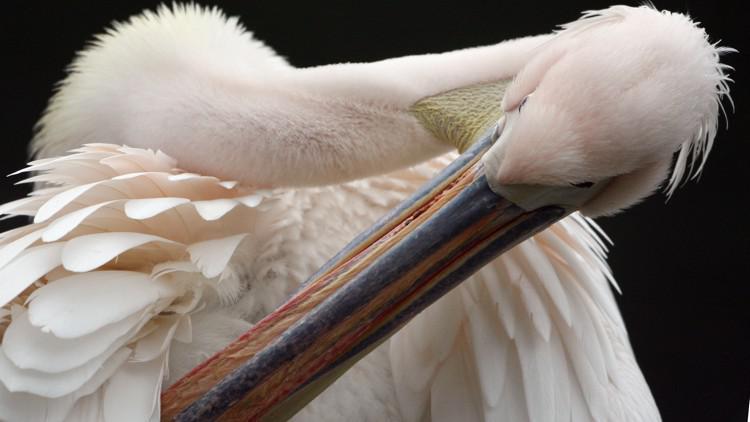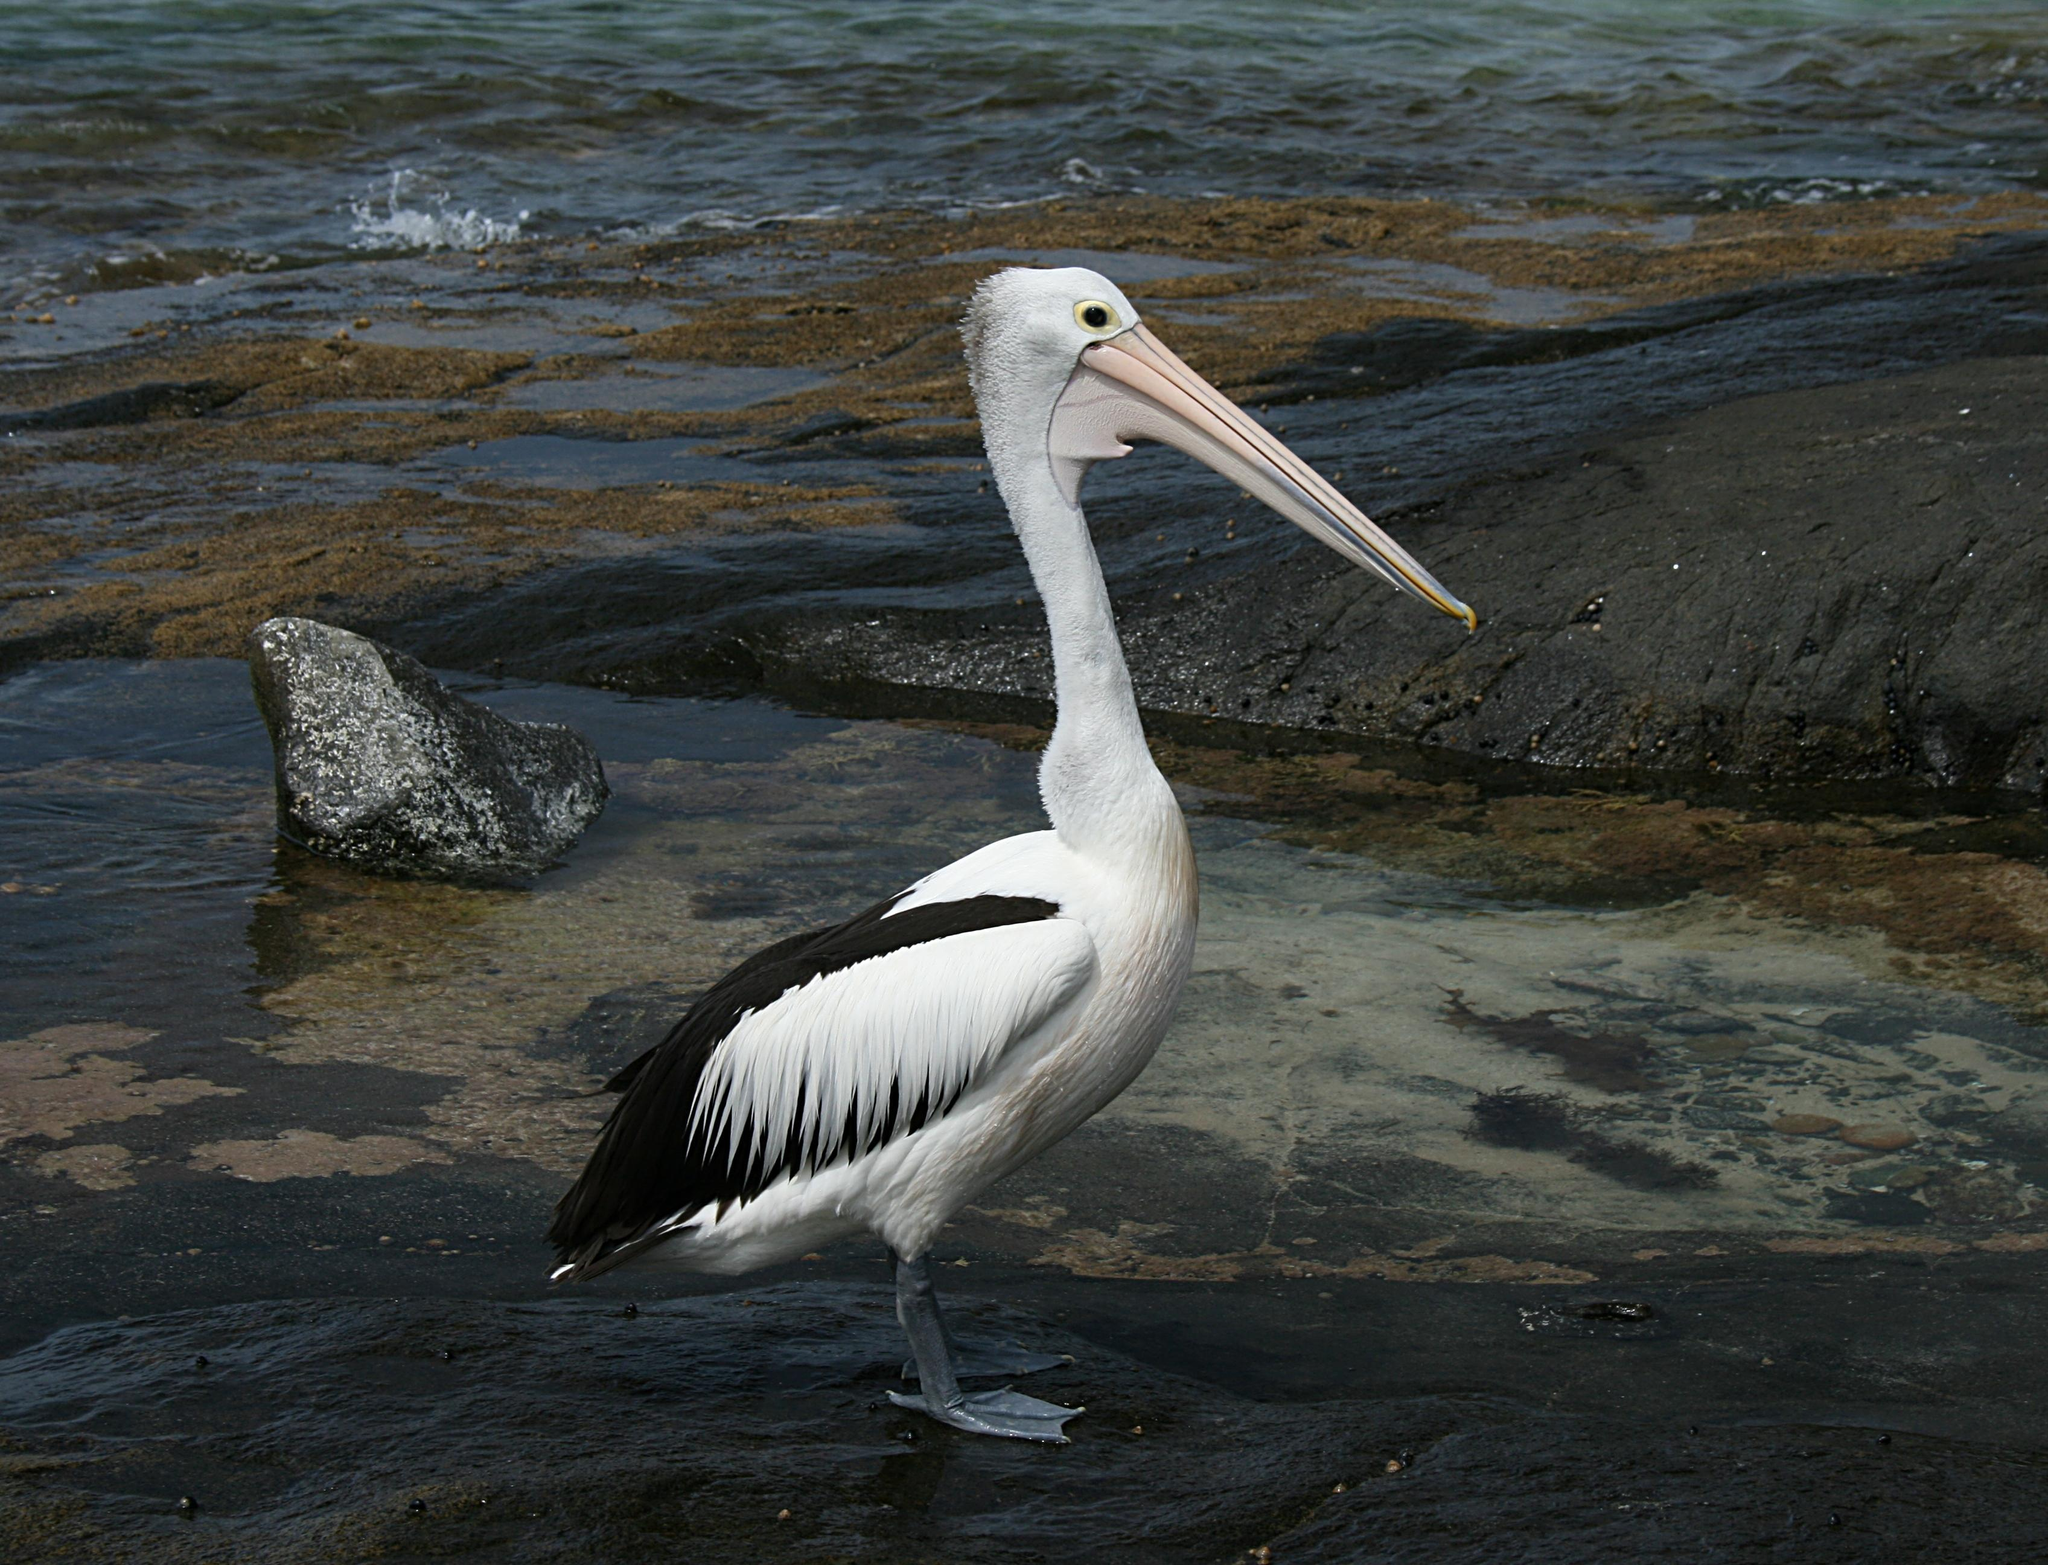The first image is the image on the left, the second image is the image on the right. For the images shown, is this caption "The left image contains at least two large birds at a beach." true? Answer yes or no. No. The first image is the image on the left, the second image is the image on the right. Examine the images to the left and right. Is the description "One of the birds is spreading its wings." accurate? Answer yes or no. No. 